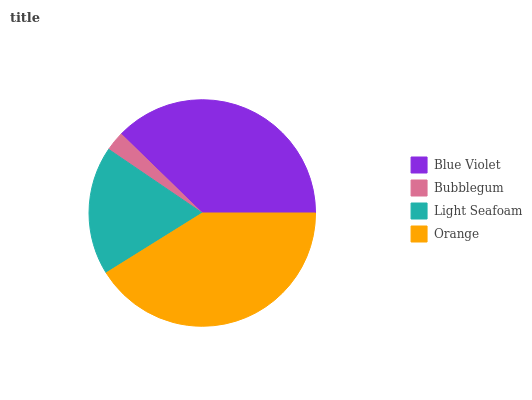Is Bubblegum the minimum?
Answer yes or no. Yes. Is Orange the maximum?
Answer yes or no. Yes. Is Light Seafoam the minimum?
Answer yes or no. No. Is Light Seafoam the maximum?
Answer yes or no. No. Is Light Seafoam greater than Bubblegum?
Answer yes or no. Yes. Is Bubblegum less than Light Seafoam?
Answer yes or no. Yes. Is Bubblegum greater than Light Seafoam?
Answer yes or no. No. Is Light Seafoam less than Bubblegum?
Answer yes or no. No. Is Blue Violet the high median?
Answer yes or no. Yes. Is Light Seafoam the low median?
Answer yes or no. Yes. Is Light Seafoam the high median?
Answer yes or no. No. Is Bubblegum the low median?
Answer yes or no. No. 